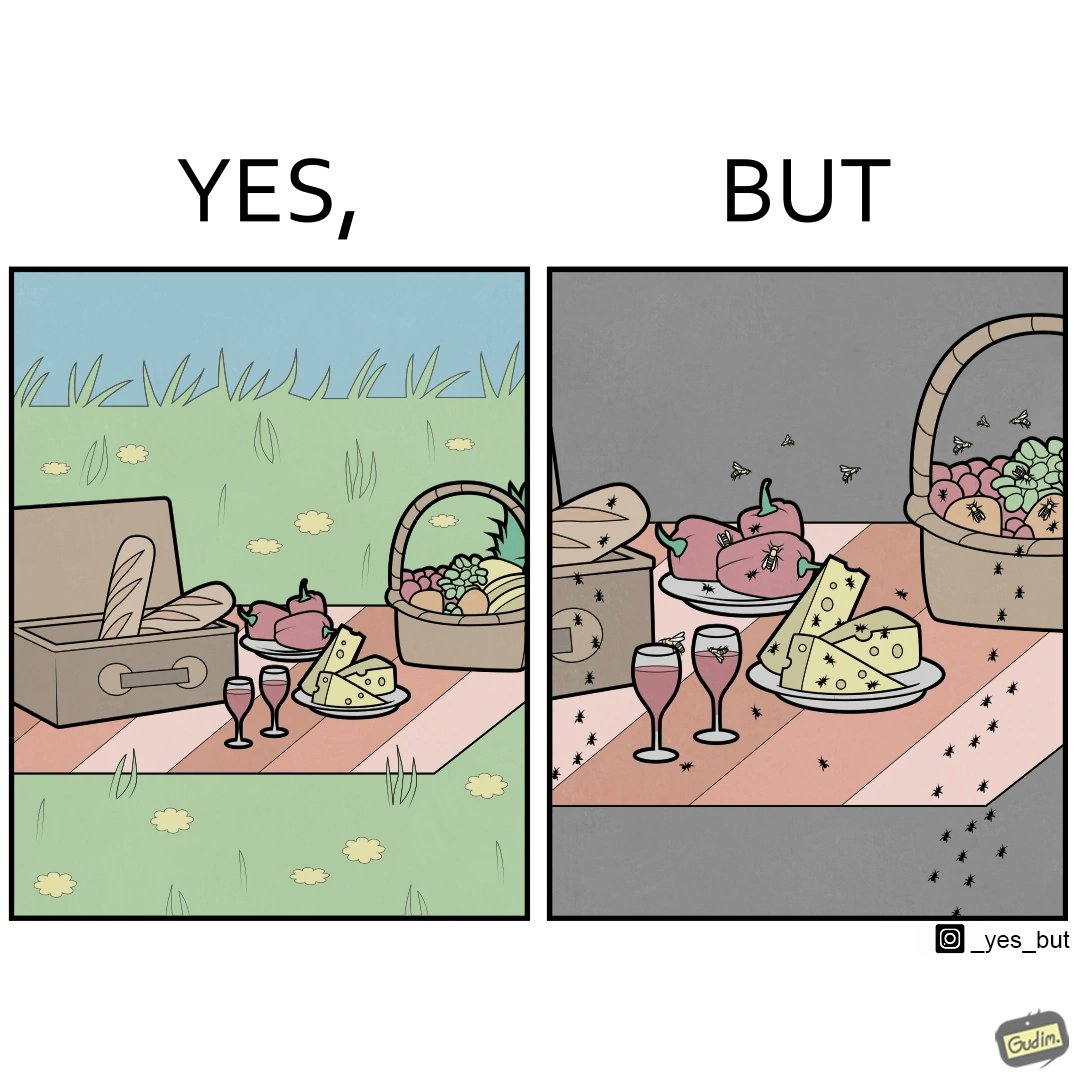What makes this image funny or satirical? The Picture shows that although we enjoy food in garden but there are some consequences of eating food in garden. Many bugs and bees are attracted towards our food and make our food sometimes non-eatable. 